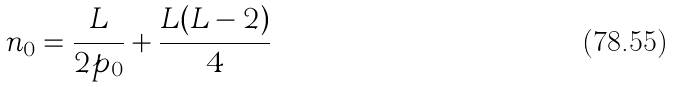Convert formula to latex. <formula><loc_0><loc_0><loc_500><loc_500>n _ { 0 } = \frac { L } { 2 p _ { 0 } } + \frac { L ( L - 2 ) } { 4 }</formula> 